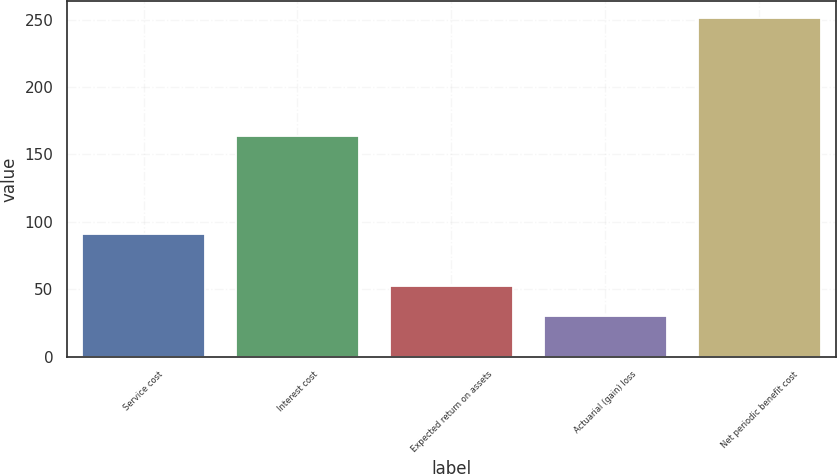<chart> <loc_0><loc_0><loc_500><loc_500><bar_chart><fcel>Service cost<fcel>Interest cost<fcel>Expected return on assets<fcel>Actuarial (gain) loss<fcel>Net periodic benefit cost<nl><fcel>91<fcel>164<fcel>52.1<fcel>30<fcel>251<nl></chart> 